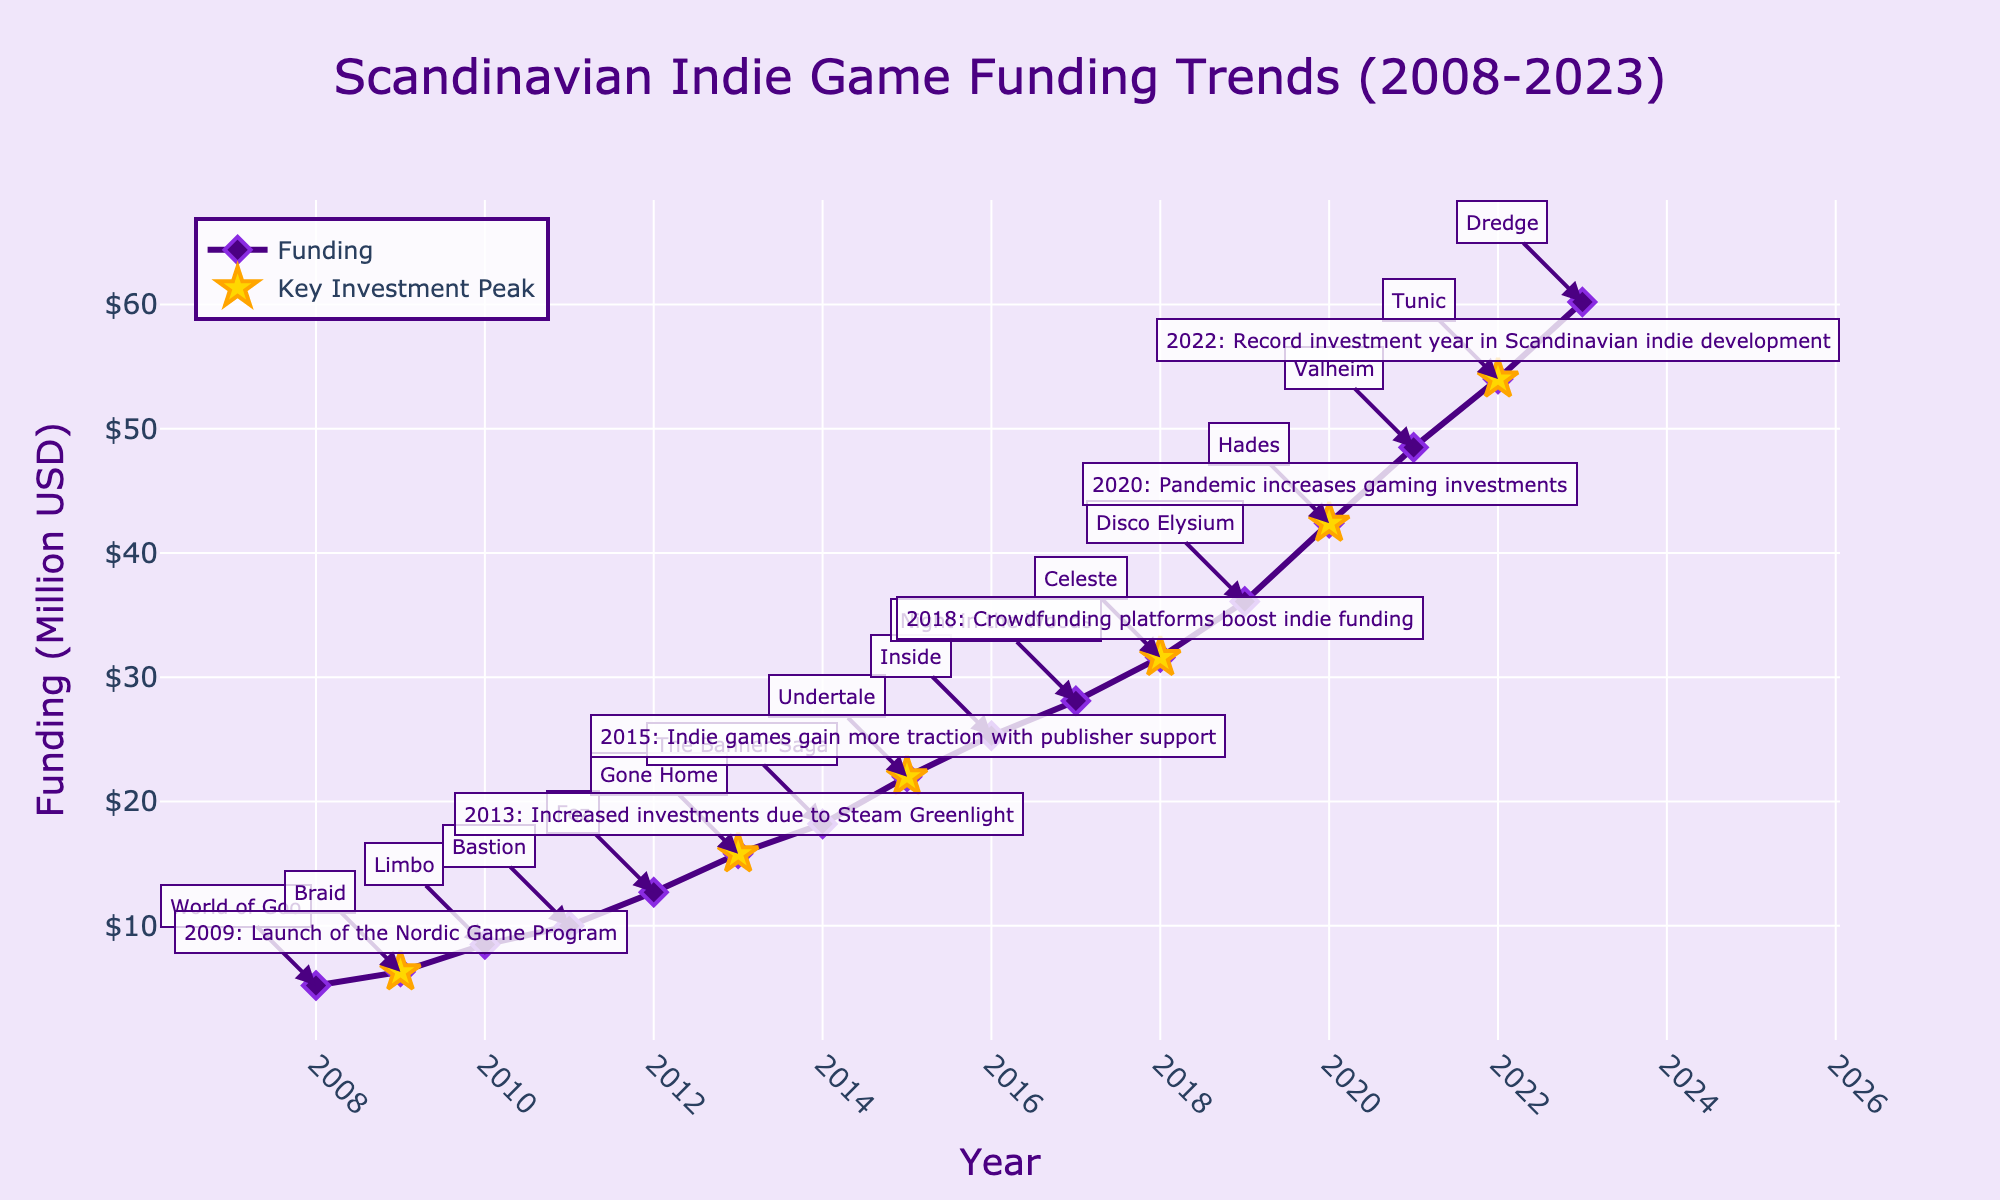what is the title of the figure? The title is located at the top center of the figure, indicating the main subject of the data being presented.
Answer: Scandinavian Indie Game Funding Trends (2008-2023) What is the funding amount in 2015? The funding amount for each year is marked by points on the line graph, and 2015 shows the data point aligned with the year and funding amount.
Answer: 22.0 million USD Which year saw the highest funding amount? The highest point on the vertical axis represents the maximum funding amount, which is indicated next to the corresponding year on the horizontal axis.
Answer: 2023 What is the difference in funding between 2013 and 2020? Identify the funding amounts for 2013 and 2020 from the line graph and subtract the smaller value from the larger one to get the difference.
Answer: 42.4 - 15.8 = 26.6 million USD How many key investment peaks are marked in the figure? Look for the star symbols or specific annotations labeled as "Key Investment Peak" on the plot, and count them.
Answer: 6 Which year marked the launch of the Nordic Game Program? Identify the annotation or star symbol associated with the launch of the Nordic Game Program and read the corresponding year on the horizontal axis.
Answer: 2009 What notable game release corresponds with the peak in 2020? Locate the star symbol or annotation for 2020, then check the nearby annotated text for the notable game release.
Answer: Hades How does the funding trend change between 2018 and 2019? Observe the slope or direction of the line connecting the data points from 2018 to 2019 to determine if it is increasing, decreasing, or constant.
Answer: Increased Compare the funding amounts in the beginning (2008) and end (2023) of the displayed period. What is the percent increase? Calculate the percent increase using the formula [(New Value - Old Value) / Old Value] * 100, where the values are the funding amounts for 2023 and 2008.
Answer: [(60.2 - 5.2) / 5.2] * 100 = 1057.7% Which year had a notable game release along with increased investments due to blockchain technology or crowdsourcing platforms? Check both the annotations for notable game releases and any mentioned key investment peaks involving blockchain technology or crowdsourcing.
Answer: 2018: Celeste 